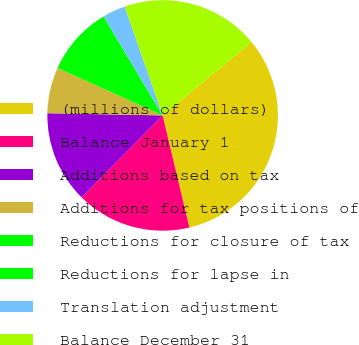Convert chart to OTSL. <chart><loc_0><loc_0><loc_500><loc_500><pie_chart><fcel>(millions of dollars)<fcel>Balance January 1<fcel>Additions based on tax<fcel>Additions for tax positions of<fcel>Reductions for closure of tax<fcel>Reductions for lapse in<fcel>Translation adjustment<fcel>Balance December 31<nl><fcel>32.25%<fcel>16.13%<fcel>12.9%<fcel>6.45%<fcel>9.68%<fcel>0.0%<fcel>3.23%<fcel>19.35%<nl></chart> 